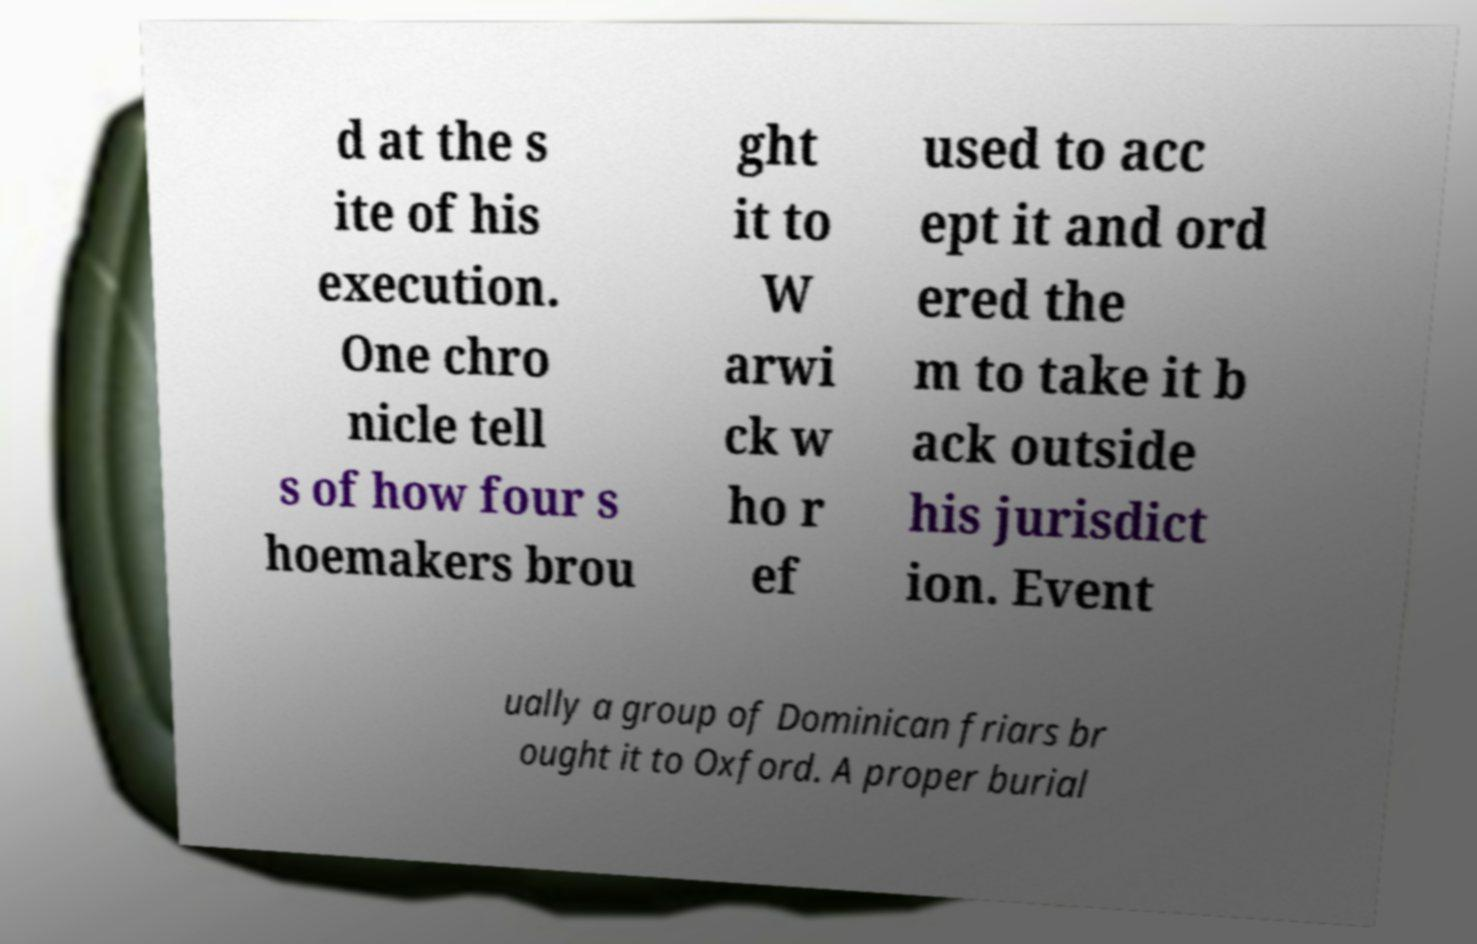What messages or text are displayed in this image? I need them in a readable, typed format. d at the s ite of his execution. One chro nicle tell s of how four s hoemakers brou ght it to W arwi ck w ho r ef used to acc ept it and ord ered the m to take it b ack outside his jurisdict ion. Event ually a group of Dominican friars br ought it to Oxford. A proper burial 